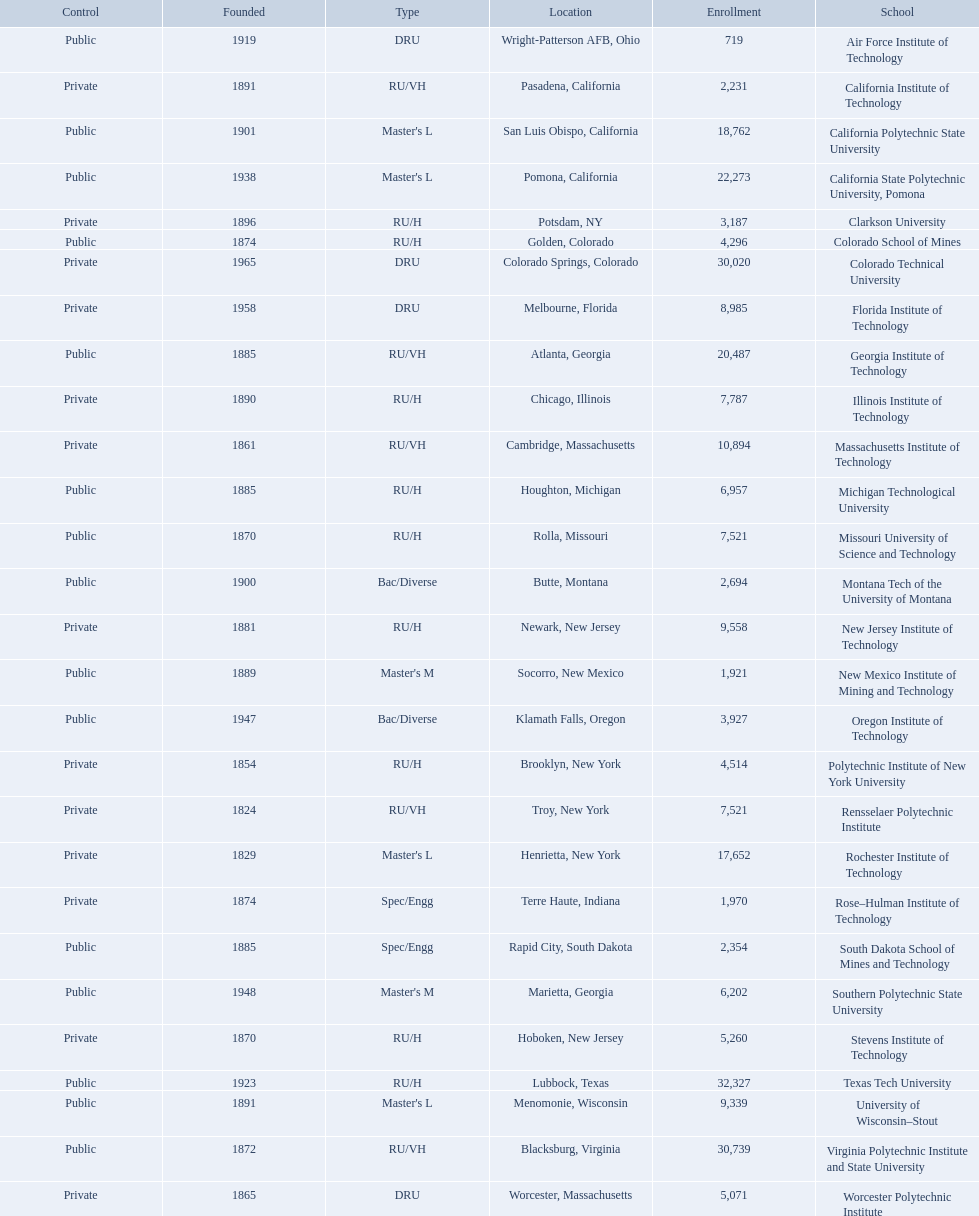What are the listed enrollment numbers of us universities? 719, 2,231, 18,762, 22,273, 3,187, 4,296, 30,020, 8,985, 20,487, 7,787, 10,894, 6,957, 7,521, 2,694, 9,558, 1,921, 3,927, 4,514, 7,521, 17,652, 1,970, 2,354, 6,202, 5,260, 32,327, 9,339, 30,739, 5,071. Of these, which has the highest value? 32,327. What are the listed names of us universities? Air Force Institute of Technology, California Institute of Technology, California Polytechnic State University, California State Polytechnic University, Pomona, Clarkson University, Colorado School of Mines, Colorado Technical University, Florida Institute of Technology, Georgia Institute of Technology, Illinois Institute of Technology, Massachusetts Institute of Technology, Michigan Technological University, Missouri University of Science and Technology, Montana Tech of the University of Montana, New Jersey Institute of Technology, New Mexico Institute of Mining and Technology, Oregon Institute of Technology, Polytechnic Institute of New York University, Rensselaer Polytechnic Institute, Rochester Institute of Technology, Rose–Hulman Institute of Technology, South Dakota School of Mines and Technology, Southern Polytechnic State University, Stevens Institute of Technology, Texas Tech University, University of Wisconsin–Stout, Virginia Polytechnic Institute and State University, Worcester Polytechnic Institute. Which of these correspond to the previously listed highest enrollment value? Texas Tech University. 